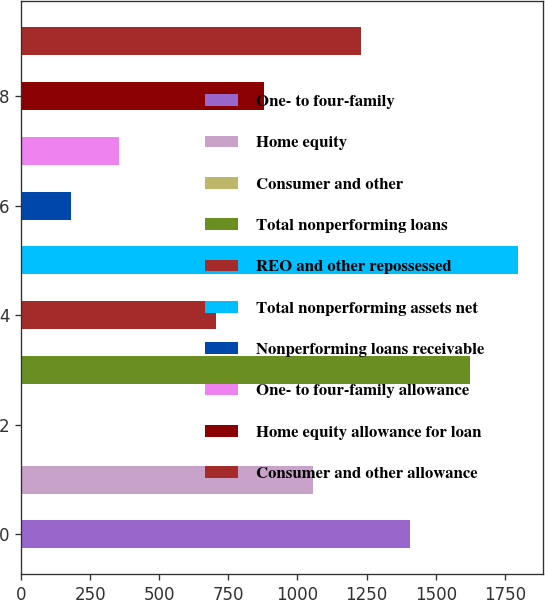Convert chart to OTSL. <chart><loc_0><loc_0><loc_500><loc_500><bar_chart><fcel>One- to four-family<fcel>Home equity<fcel>Consumer and other<fcel>Total nonperforming loans<fcel>REO and other repossessed<fcel>Total nonperforming assets net<fcel>Nonperforming loans receivable<fcel>One- to four-family allowance<fcel>Home equity allowance for loan<fcel>Consumer and other allowance<nl><fcel>1405.9<fcel>1055.8<fcel>5.5<fcel>1622.5<fcel>705.7<fcel>1797.55<fcel>180.55<fcel>355.6<fcel>880.75<fcel>1230.85<nl></chart> 